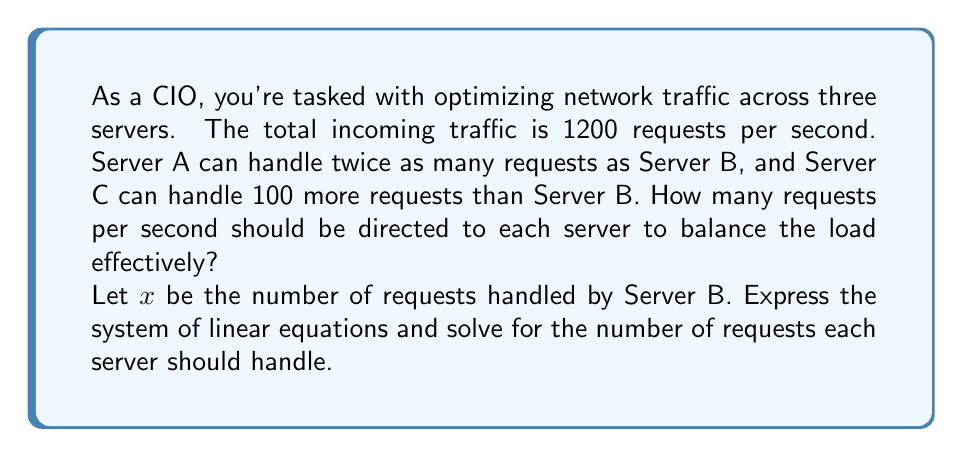Help me with this question. Let's approach this step-by-step:

1) Define variables:
   Let $x$ = requests handled by Server B
       $2x$ = requests handled by Server A (twice as many as B)
       $x + 100$ = requests handled by Server C (100 more than B)

2) Set up the equation based on total traffic:
   $2x + x + (x + 100) = 1200$

3) Simplify the equation:
   $4x + 100 = 1200$

4) Subtract 100 from both sides:
   $4x = 1100$

5) Divide both sides by 4:
   $x = 275$

6) Now that we know $x$, we can calculate for each server:
   Server B: $x = 275$ requests
   Server A: $2x = 2(275) = 550$ requests
   Server C: $x + 100 = 275 + 100 = 375$ requests

7) Verify the solution:
   $550 + 275 + 375 = 1200$ (total traffic)

This solution ensures that the load is balanced according to the given constraints, with Server A handling twice as much as B, and Server C handling 100 more than B.
Answer: Server A: 550 requests/second
Server B: 275 requests/second
Server C: 375 requests/second 